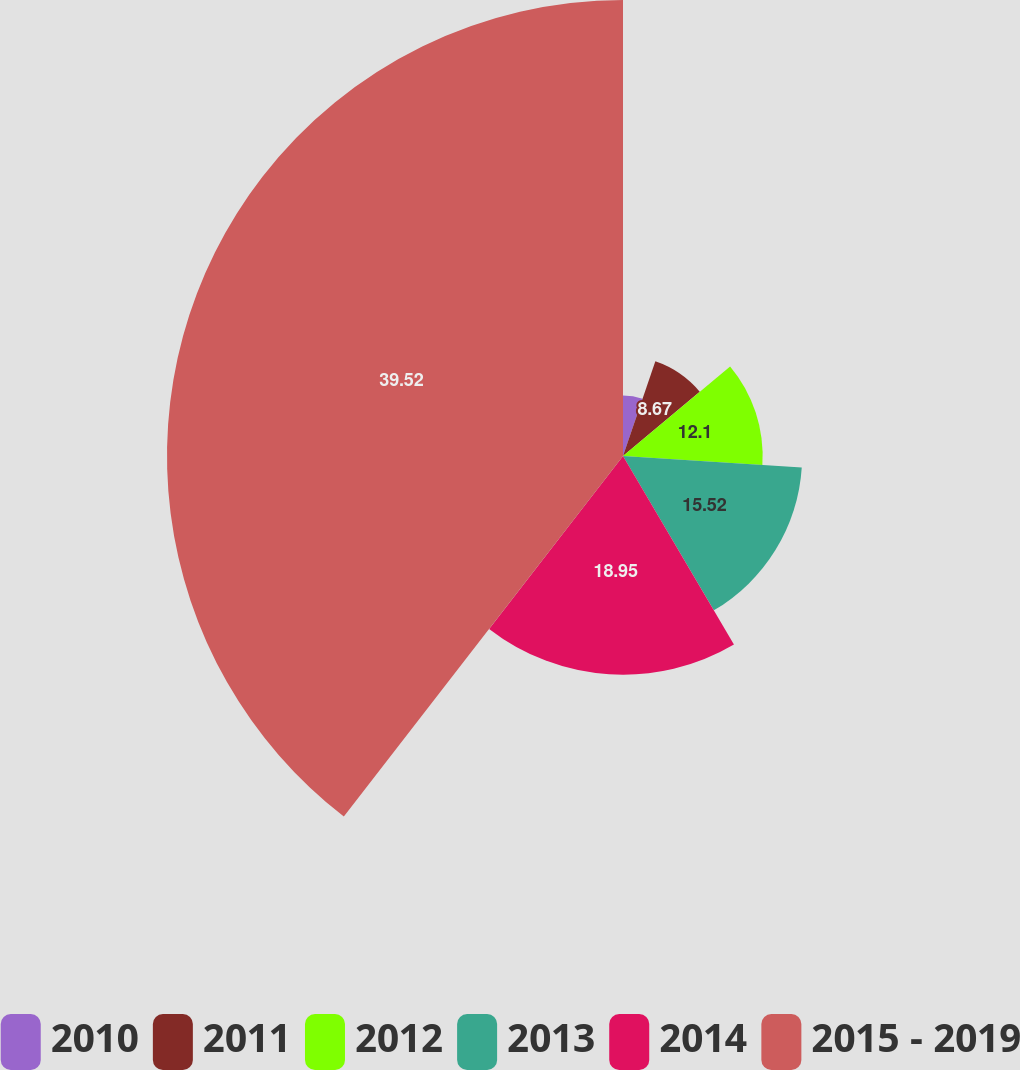<chart> <loc_0><loc_0><loc_500><loc_500><pie_chart><fcel>2010<fcel>2011<fcel>2012<fcel>2013<fcel>2014<fcel>2015 - 2019<nl><fcel>5.24%<fcel>8.67%<fcel>12.1%<fcel>15.52%<fcel>18.95%<fcel>39.51%<nl></chart> 